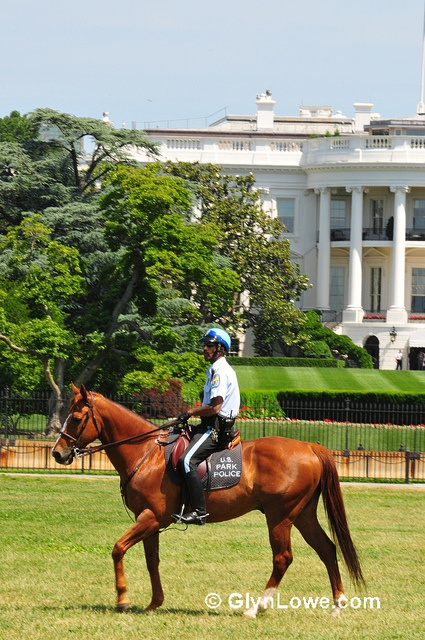Describe the objects in this image and their specific colors. I can see horse in lightgray, black, maroon, and brown tones, people in lightgray, black, white, gray, and maroon tones, people in lightgray, black, and gray tones, people in lightgray, black, darkgray, and gray tones, and people in lightgray, black, gray, and darkgray tones in this image. 